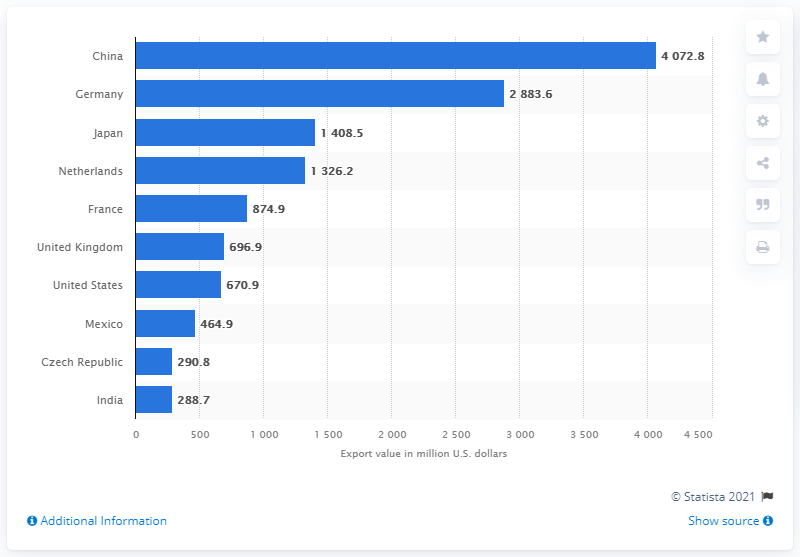Highlight a few significant elements in this photo. In 2019, China was the leading exporter of office supplies to the rest of the world. In 2019, the value of China's exports in U.S. dollars was 4072.8. In 2019, Germany exported 2883.6 office supplies to the United States. 